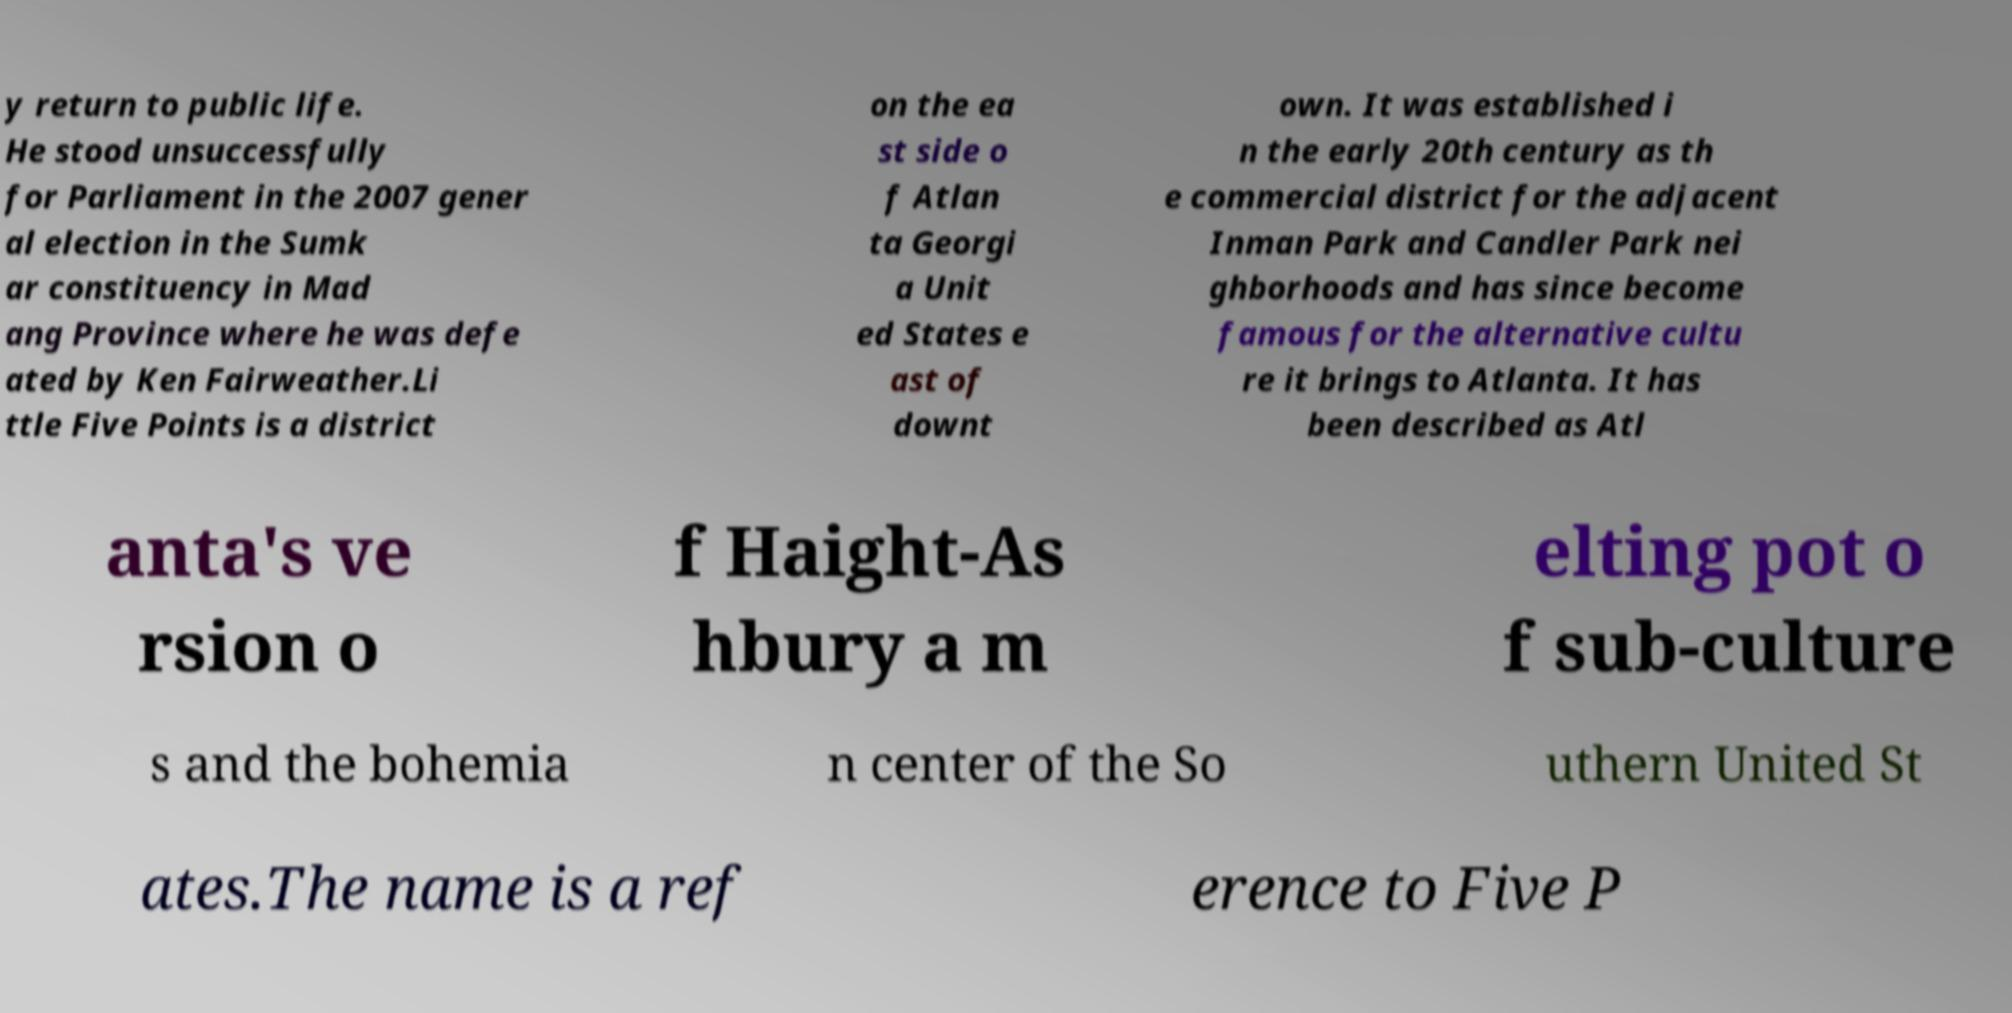What messages or text are displayed in this image? I need them in a readable, typed format. y return to public life. He stood unsuccessfully for Parliament in the 2007 gener al election in the Sumk ar constituency in Mad ang Province where he was defe ated by Ken Fairweather.Li ttle Five Points is a district on the ea st side o f Atlan ta Georgi a Unit ed States e ast of downt own. It was established i n the early 20th century as th e commercial district for the adjacent Inman Park and Candler Park nei ghborhoods and has since become famous for the alternative cultu re it brings to Atlanta. It has been described as Atl anta's ve rsion o f Haight-As hbury a m elting pot o f sub-culture s and the bohemia n center of the So uthern United St ates.The name is a ref erence to Five P 